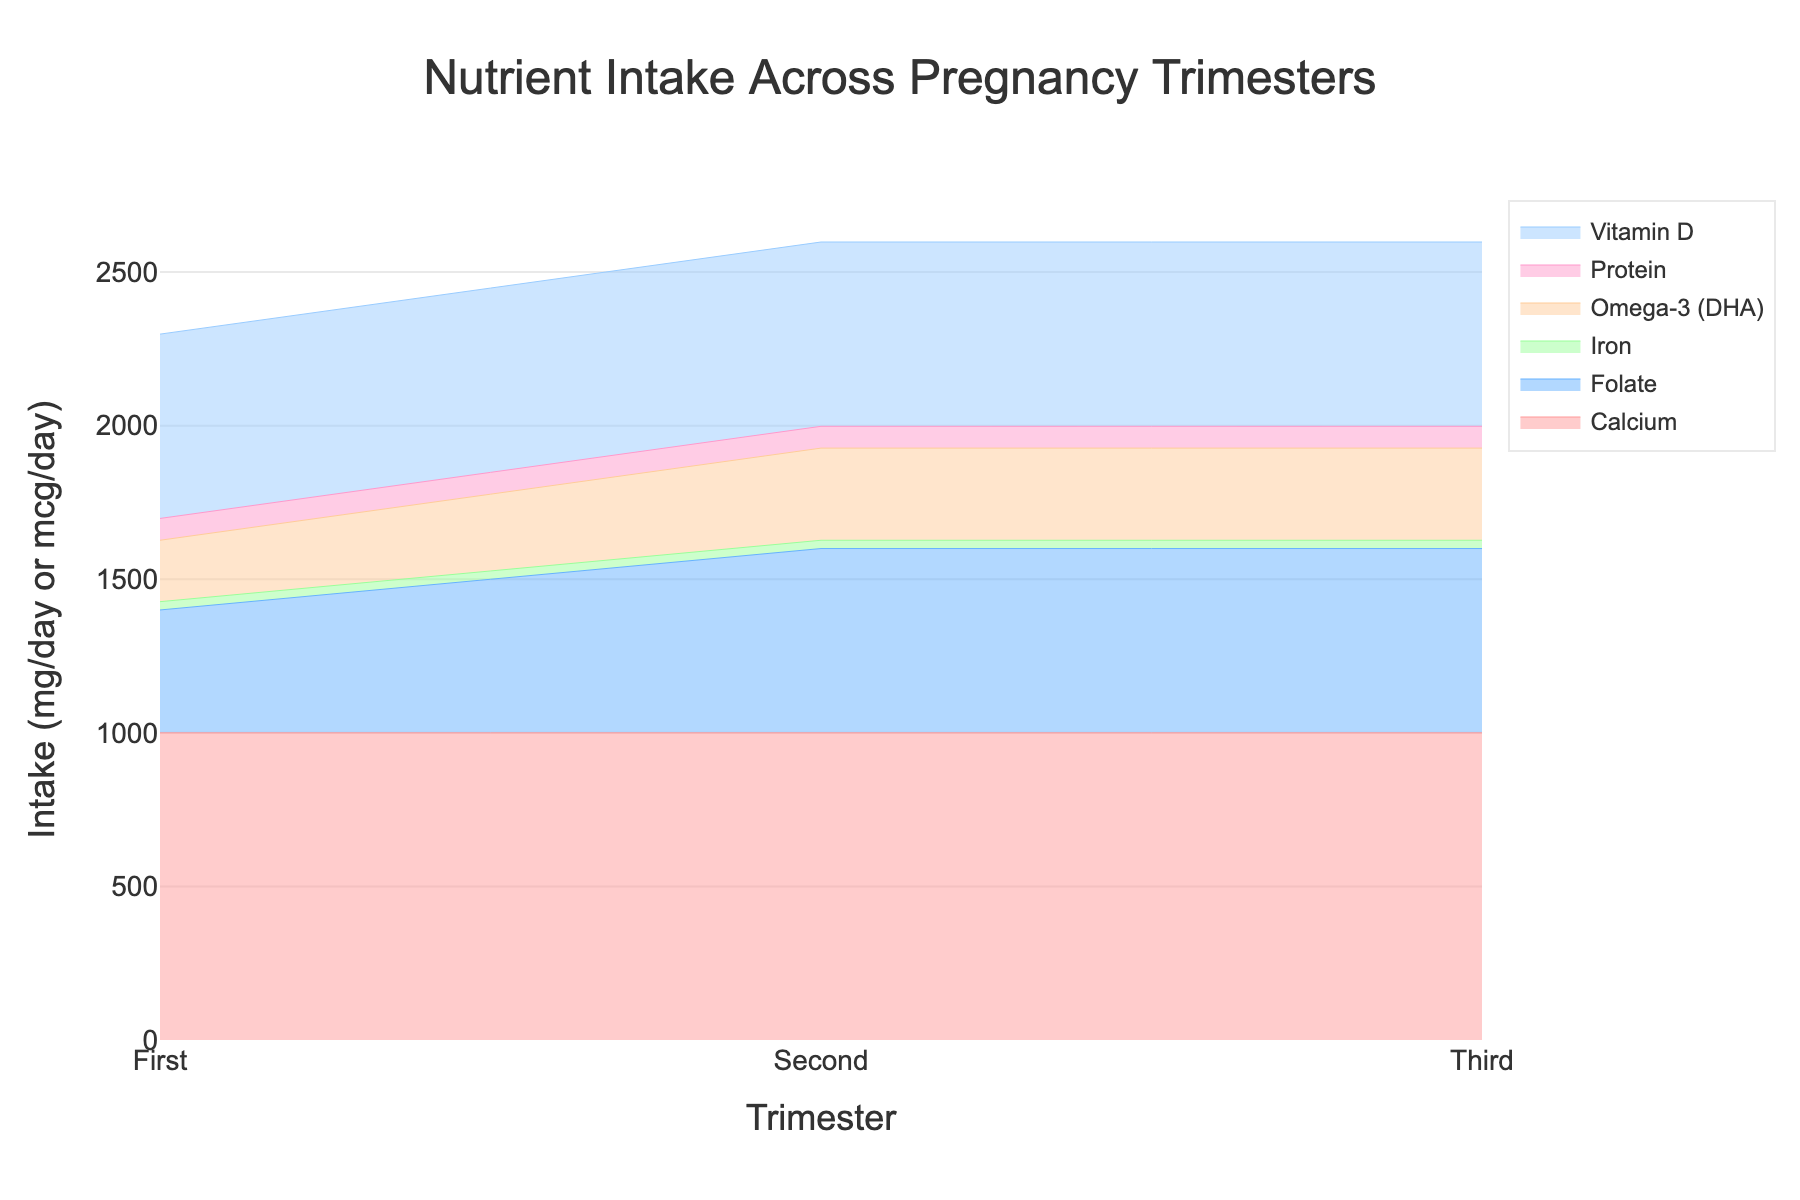what is the title of this chart? The title is displayed prominently at the top of the chart and summarizes the subject of the chart. The title reads "Nutrient Intake Across Pregnancy Trimesters".
Answer: Nutrient Intake Across Pregnancy Trimesters what does the x-axis represent? The x-axis is labeled as "Trimester", which indicates that it represents the three stages of pregnancy: First, Second, and Third trimesters.
Answer: Trimester how many nutrients are depicted in the chart? The chart has a legend showing the names of the nutrients, and it has six different colors, each representing a different nutrient (Iron, Folate, Calcium, Vitamin D, Protein, Omega-3 (DHA)).
Answer: Six which nutrient has a consistent intake value across all trimesters? By looking at the step area chart, we can see that the intake value of Iron remains constant as there are no changes in the height of the filled area for Iron across different trimesters.
Answer: Iron what is the intake value of folate during the second trimester? The intake value for Folate during the second trimester can be observed by tracking the height of the Folate area on the y-axis at the second trimester point. The value is 600 mcg/day.
Answer: 600 mcg/day which nutrient has an increased intake requirement in the third trimester compared to the first trimester? We can see that the area for Omega-3 (DHA) increases from 200 to 300 between the first and third trimesters. By comparing the areas, we identify that Omega-3 (DHA) is the nutrient with an increased intake.
Answer: Omega-3 (DHA) what is the difference in folate intake between the first and second trimesters? We calculate the difference by subtracting the first trimester value (400 mcg/day) from the second trimester value (600 mcg/day), resulting in a difference of 200 mcg/day.
Answer: 200 mcg/day list the nutrients that do not change their intake requirements throughout the trimesters. By inspecting the step areas, we identify that Iron, Calcium, Vitamin D, and Protein have flat areas that do not show changes across the trimesters.
Answer: Iron, Calcium, Vitamin D, Protein is there any nutrient whose intake decreases in any trimester? Viewing the step area chart, we see that none of the nutrient intake areas show a downward step between the trimesters. All the nutrients either increase or remain the same.
Answer: No compare the intake of calcium and protein in the first trimester. The intake values for Calcium and Protein during the first trimester can be seen on the y-axis. Both values are 1000 mg/day for Calcium and 71 g/day for Protein. Therefore, Calcium intake is higher.
Answer: Calcium 